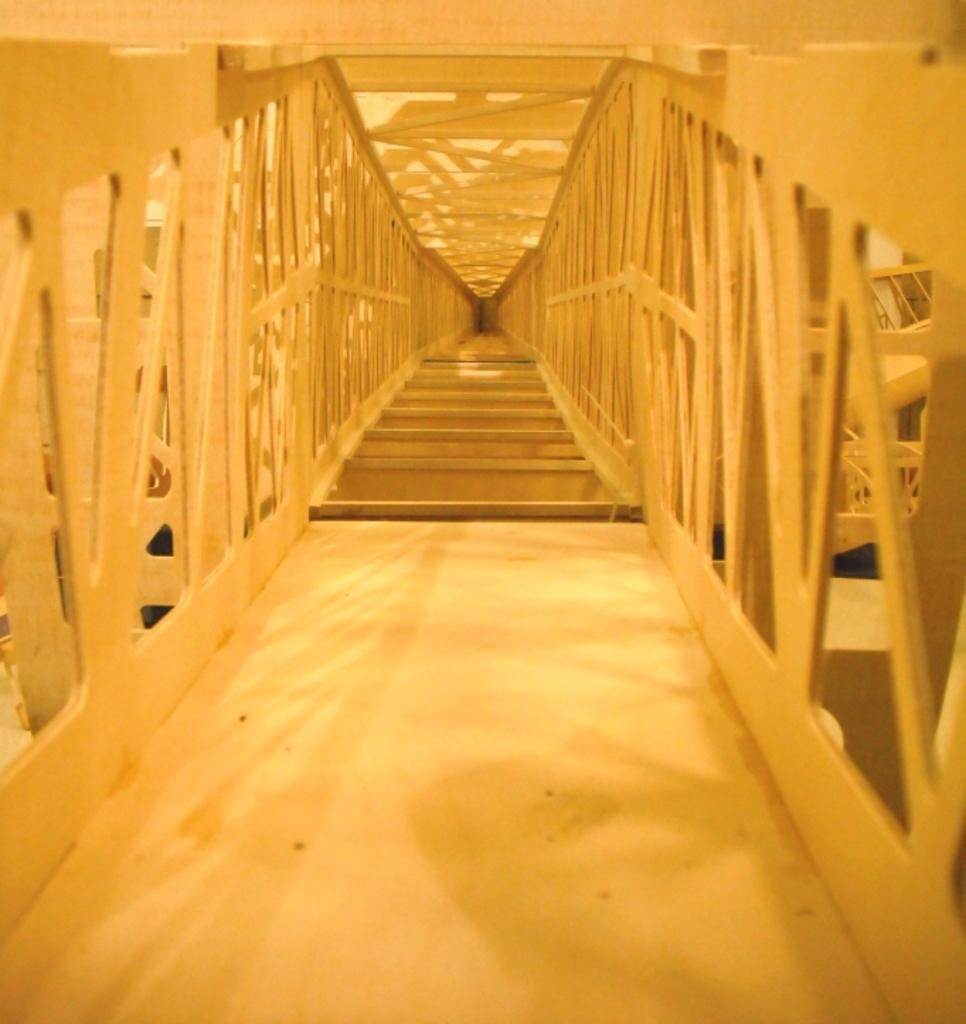Could you give a brief overview of what you see in this image? In the picture I can see steps, fence and some other metal objects. 